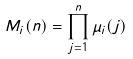Convert formula to latex. <formula><loc_0><loc_0><loc_500><loc_500>M _ { i } ( n ) = \prod _ { j = 1 } ^ { n } \mu _ { i } ( j )</formula> 